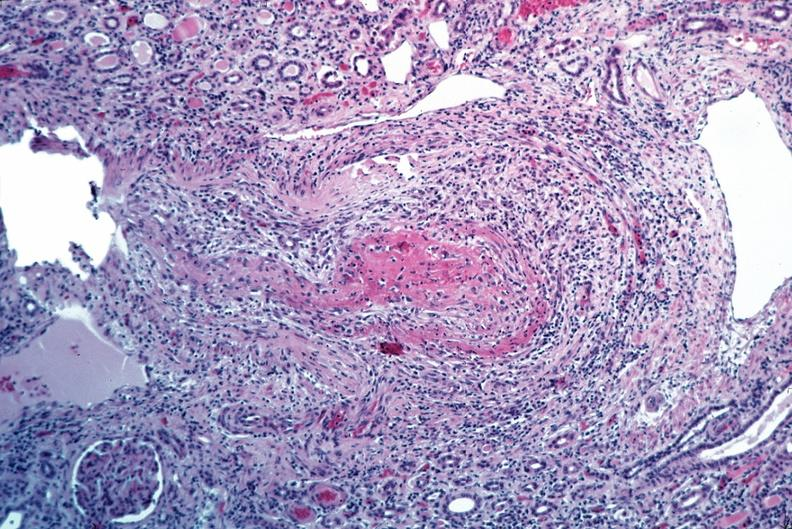does this image show vasculitis, polyarteritis nodosa?
Answer the question using a single word or phrase. Yes 